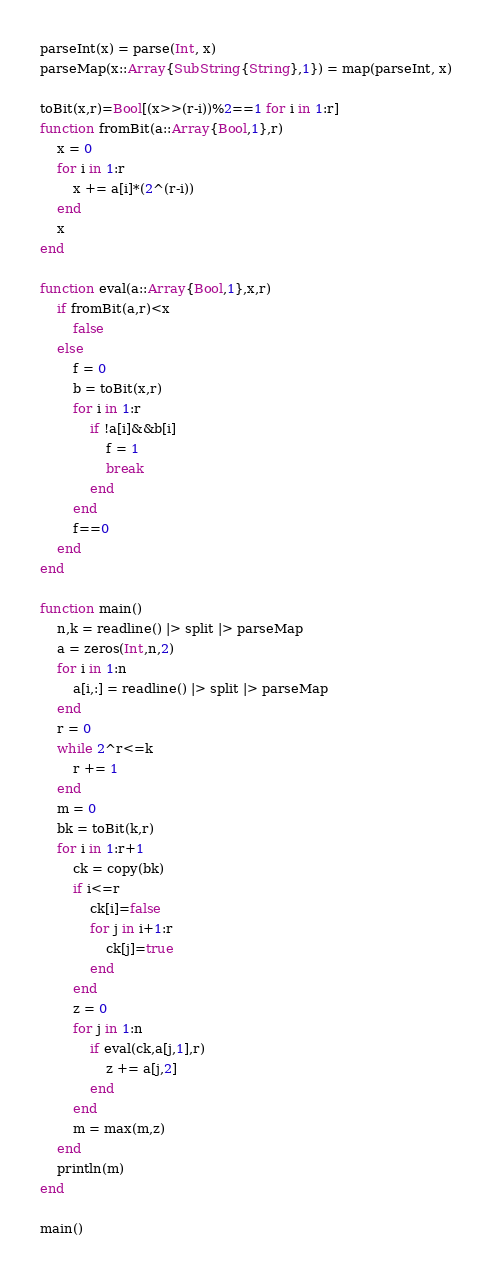Convert code to text. <code><loc_0><loc_0><loc_500><loc_500><_Julia_>parseInt(x) = parse(Int, x)
parseMap(x::Array{SubString{String},1}) = map(parseInt, x)

toBit(x,r)=Bool[(x>>(r-i))%2==1 for i in 1:r]
function fromBit(a::Array{Bool,1},r)
	x = 0
	for i in 1:r
		x += a[i]*(2^(r-i))
	end
	x
end
	
function eval(a::Array{Bool,1},x,r)
	if fromBit(a,r)<x
		false
	else
		f = 0
		b = toBit(x,r)
		for i in 1:r
			if !a[i]&&b[i]
				f = 1
				break
			end
		end
		f==0
	end
end

function main()
	n,k = readline() |> split |> parseMap
	a = zeros(Int,n,2)
	for i in 1:n
		a[i,:] = readline() |> split |> parseMap
	end
	r = 0
	while 2^r<=k
		r += 1
	end
	m = 0
	bk = toBit(k,r)
	for i in 1:r+1
		ck = copy(bk)
		if i<=r
			ck[i]=false
			for j in i+1:r
				ck[j]=true
			end
		end
		z = 0
		for j in 1:n
			if eval(ck,a[j,1],r)
				z += a[j,2]
			end
		end
		m = max(m,z)
	end
	println(m)
end

main()</code> 